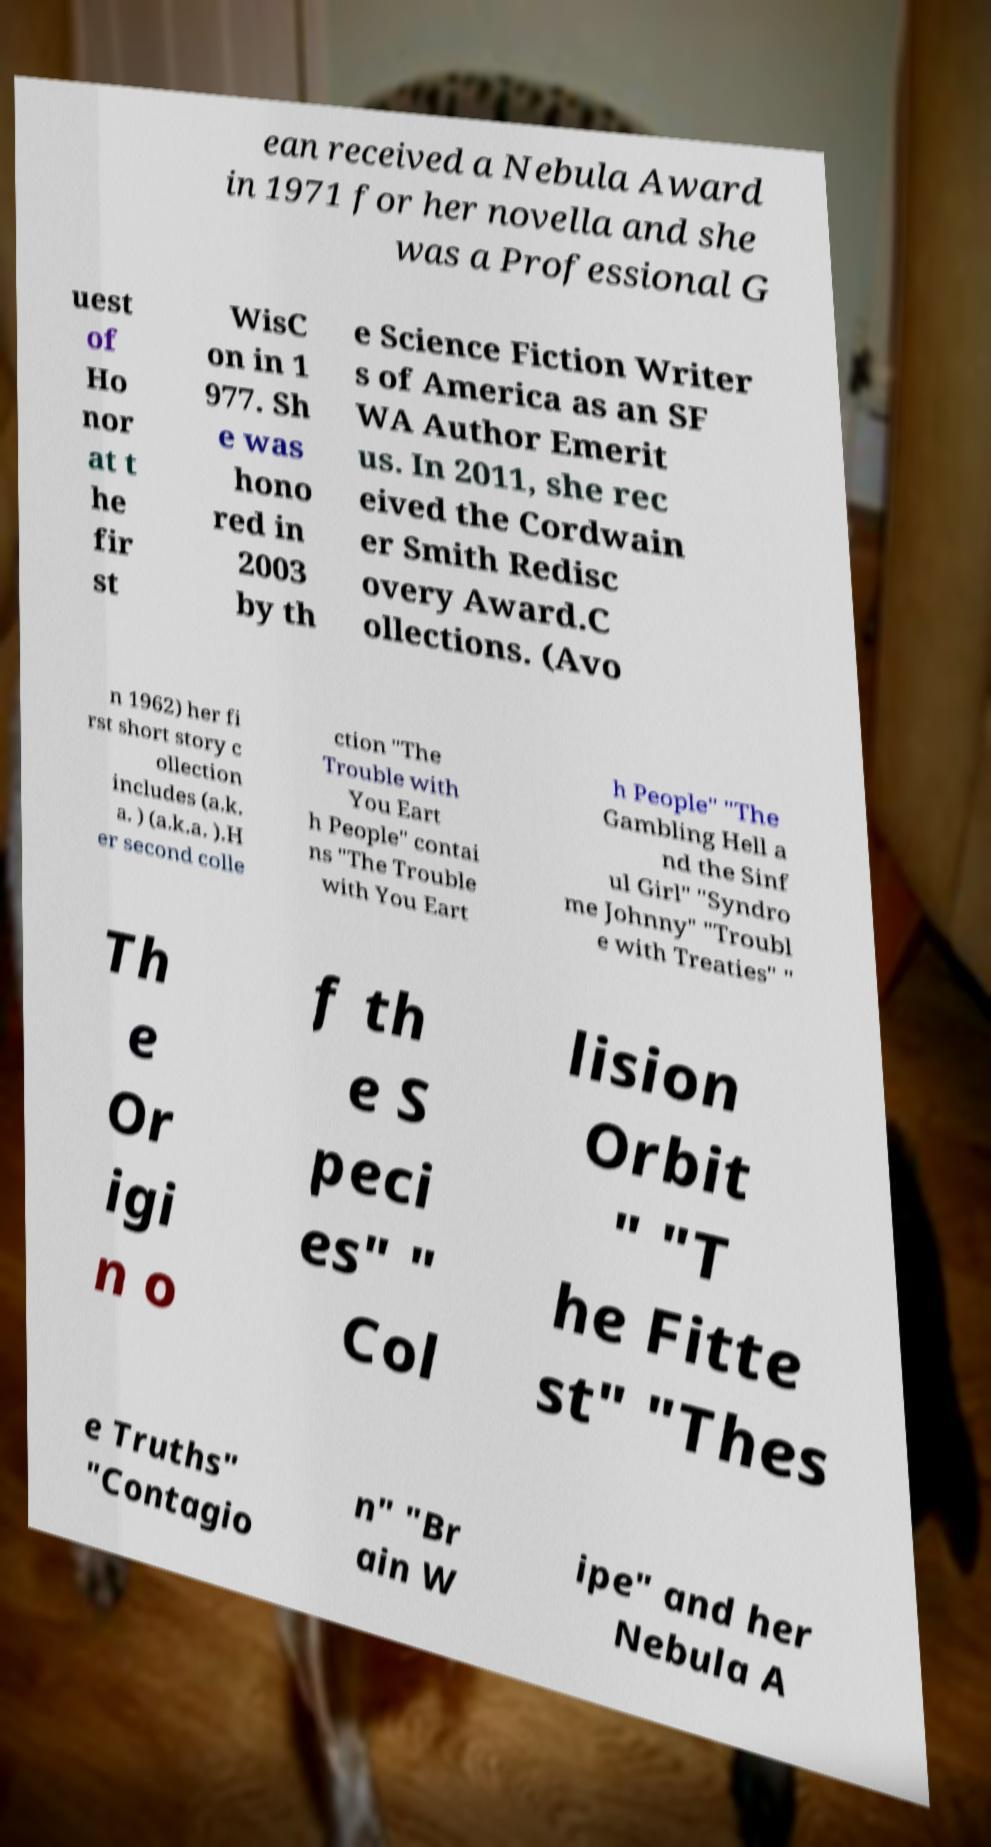Could you extract and type out the text from this image? ean received a Nebula Award in 1971 for her novella and she was a Professional G uest of Ho nor at t he fir st WisC on in 1 977. Sh e was hono red in 2003 by th e Science Fiction Writer s of America as an SF WA Author Emerit us. In 2011, she rec eived the Cordwain er Smith Redisc overy Award.C ollections. (Avo n 1962) her fi rst short story c ollection includes (a.k. a. ) (a.k.a. ).H er second colle ction "The Trouble with You Eart h People" contai ns "The Trouble with You Eart h People" "The Gambling Hell a nd the Sinf ul Girl" "Syndro me Johnny" "Troubl e with Treaties" " Th e Or igi n o f th e S peci es" " Col lision Orbit " "T he Fitte st" "Thes e Truths" "Contagio n" "Br ain W ipe" and her Nebula A 